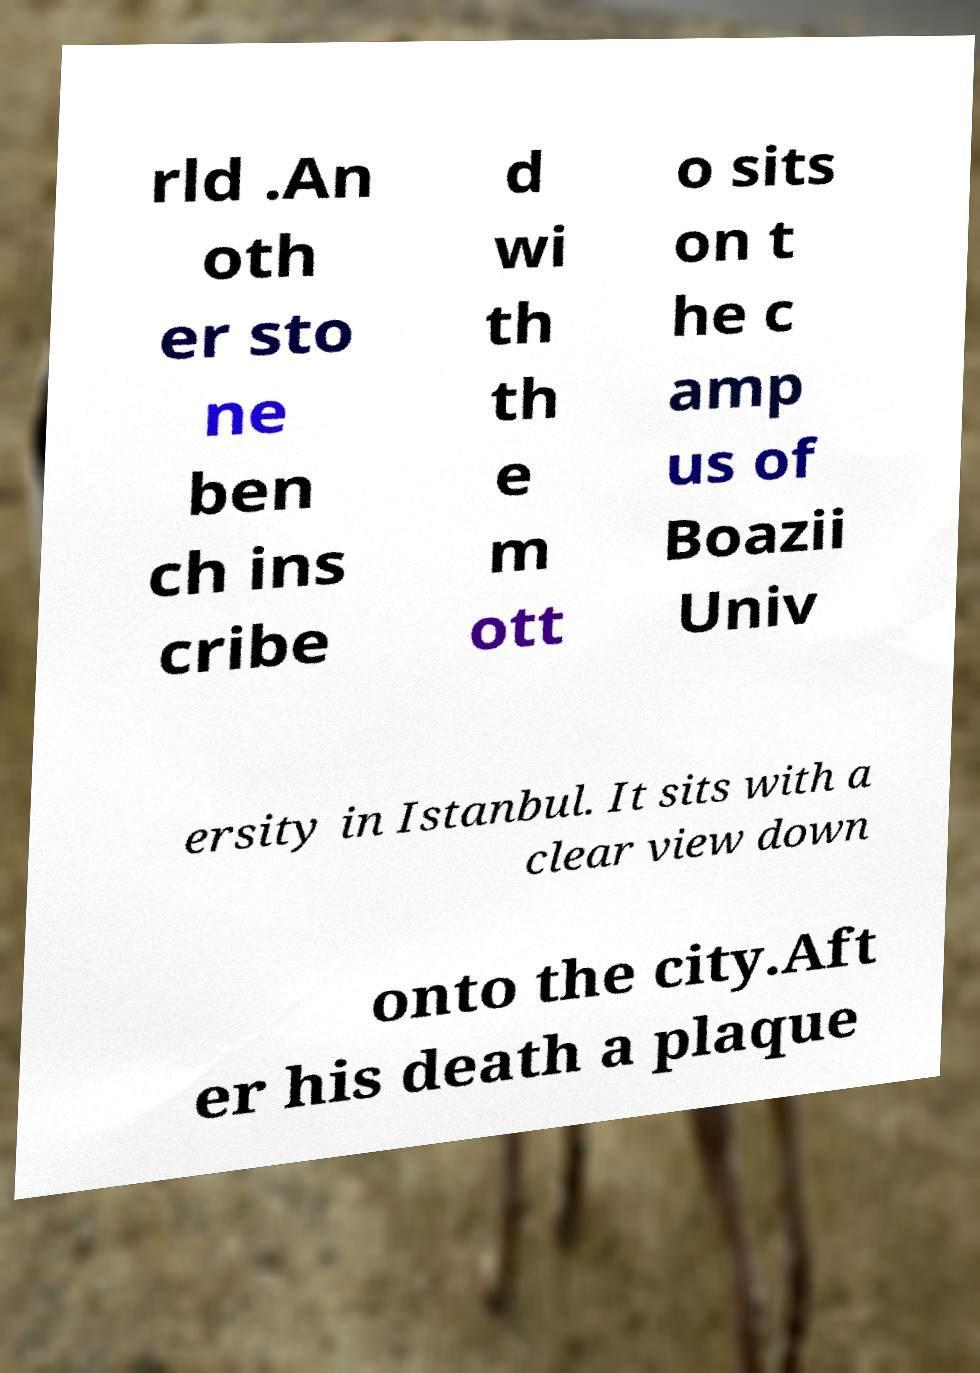Can you read and provide the text displayed in the image?This photo seems to have some interesting text. Can you extract and type it out for me? rld .An oth er sto ne ben ch ins cribe d wi th th e m ott o sits on t he c amp us of Boazii Univ ersity in Istanbul. It sits with a clear view down onto the city.Aft er his death a plaque 